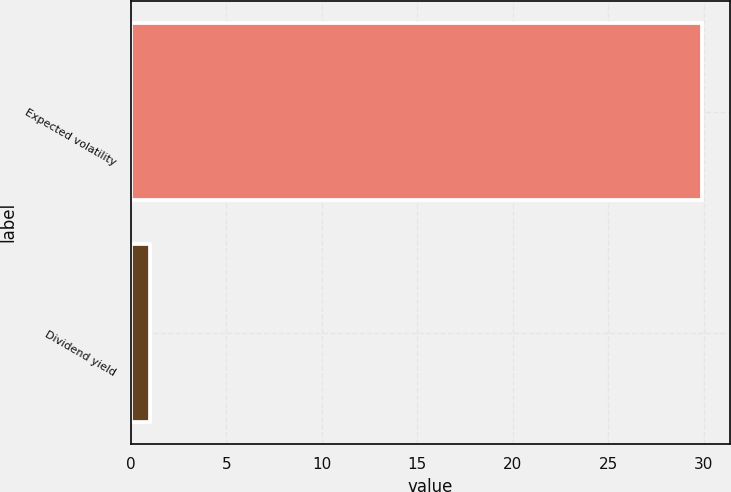<chart> <loc_0><loc_0><loc_500><loc_500><bar_chart><fcel>Expected volatility<fcel>Dividend yield<nl><fcel>29.9<fcel>1<nl></chart> 